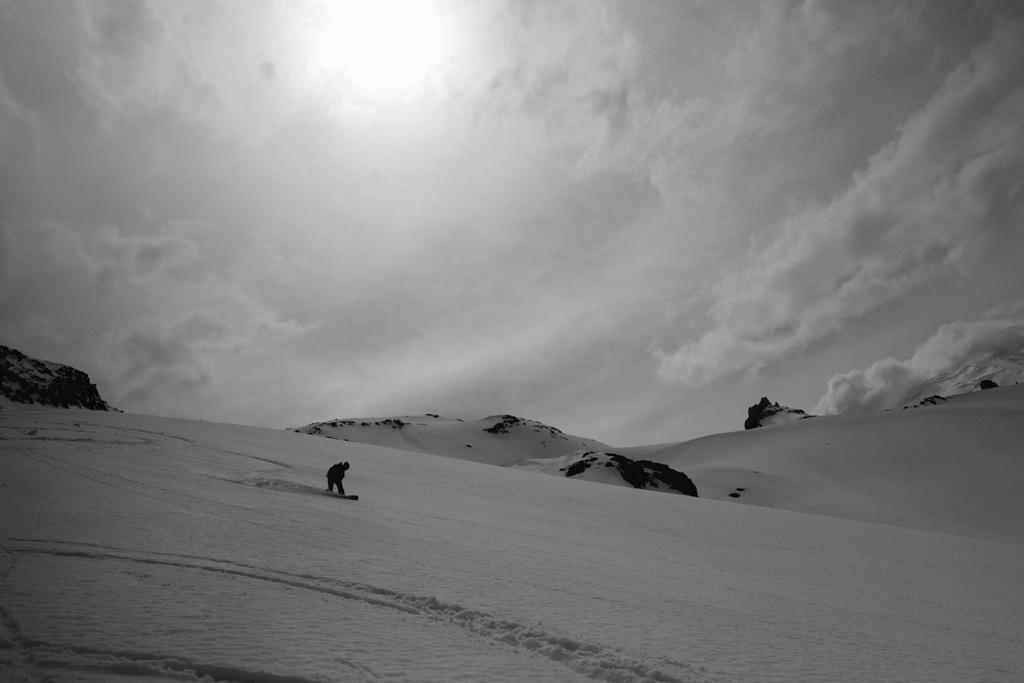What activity is the person in the image engaged in? The person is skiing in the image. What surface is the person skiing on? The person is skiing on snow. What other natural elements can be seen in the image? There are rocks visible in the image. What is the condition of the sky in the image? The sky is clouded in the image. Can you see the person's mother skiing with them in the image? There is no indication of the person's mother being present in the image. Are there any fairies visible in the image? There are no fairies present in the image. 